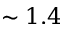Convert formula to latex. <formula><loc_0><loc_0><loc_500><loc_500>\sim 1 . 4</formula> 